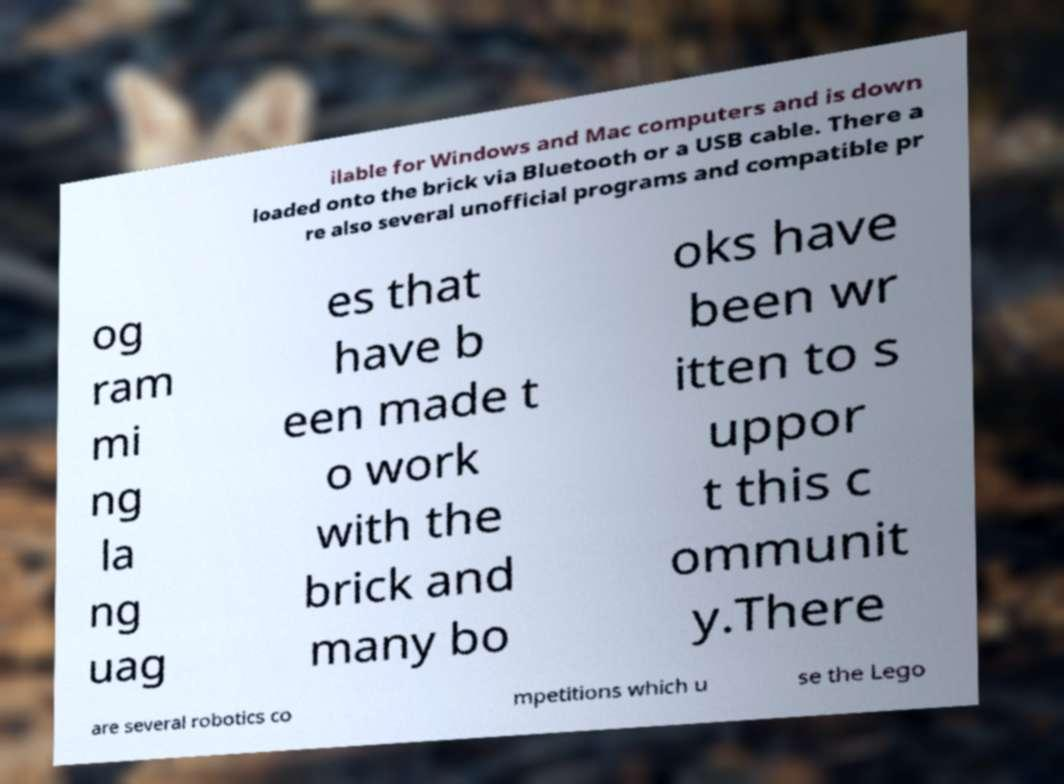What messages or text are displayed in this image? I need them in a readable, typed format. ilable for Windows and Mac computers and is down loaded onto the brick via Bluetooth or a USB cable. There a re also several unofficial programs and compatible pr og ram mi ng la ng uag es that have b een made t o work with the brick and many bo oks have been wr itten to s uppor t this c ommunit y.There are several robotics co mpetitions which u se the Lego 